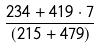Convert formula to latex. <formula><loc_0><loc_0><loc_500><loc_500>\frac { 2 3 4 + 4 1 9 \cdot 7 } { ( 2 1 5 + 4 7 9 ) }</formula> 